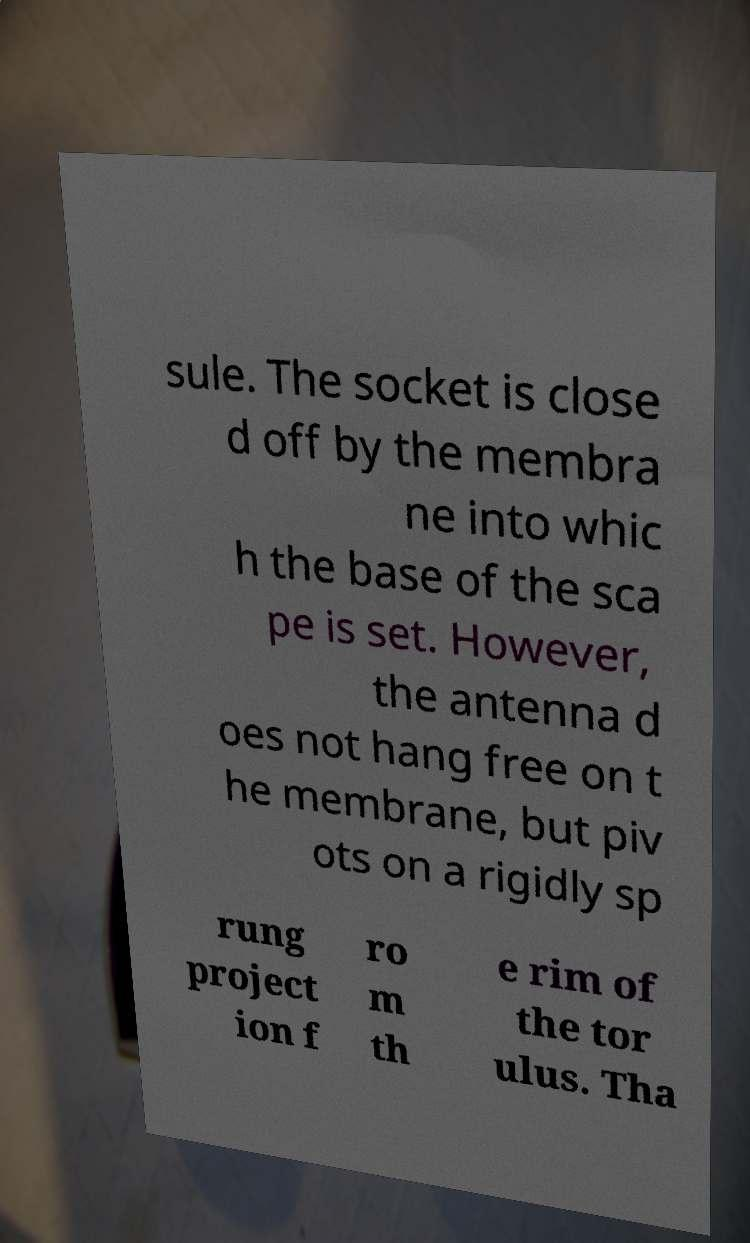There's text embedded in this image that I need extracted. Can you transcribe it verbatim? sule. The socket is close d off by the membra ne into whic h the base of the sca pe is set. However, the antenna d oes not hang free on t he membrane, but piv ots on a rigidly sp rung project ion f ro m th e rim of the tor ulus. Tha 